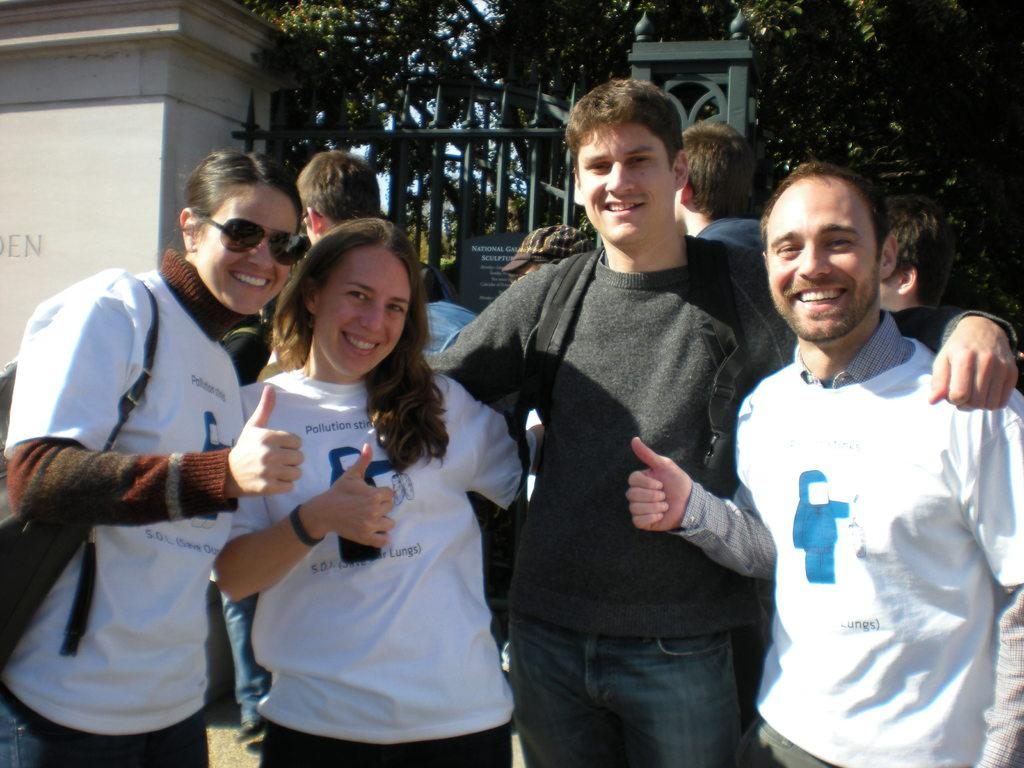How many people are in the image? There are two men and two women in the image, making a total of four people. What are the individuals doing in the image? The individuals are showing their thumbs up in the image. What structures can be seen in the image? There is a gate and a wall in the image. What is visible behind the wall? Trees are visible behind the wall in the image. What type of bone can be seen in the image? There is no bone present in the image. Can you describe the cloud formation in the image? There is no cloud formation in the image; it is focused on the people, gate, wall, and trees. 